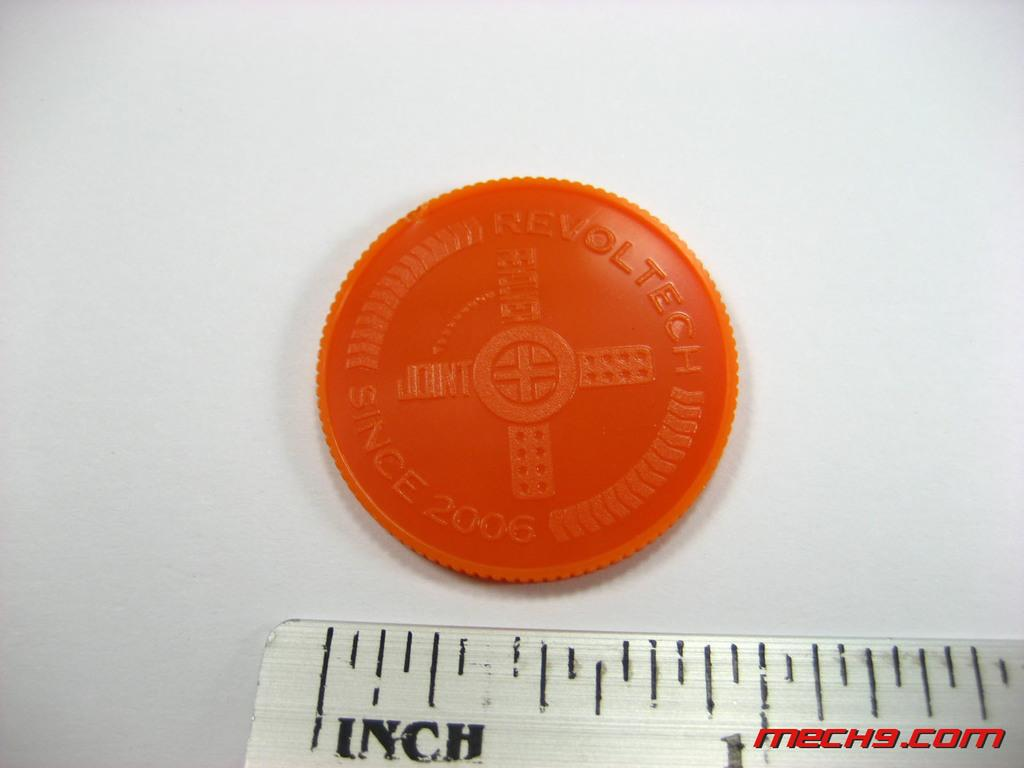<image>
Render a clear and concise summary of the photo. A orange token reading Revoltech placed above a ruler. 